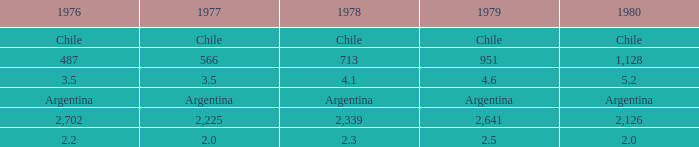What is 1976 when 1977 is 3.5? 3.5. 